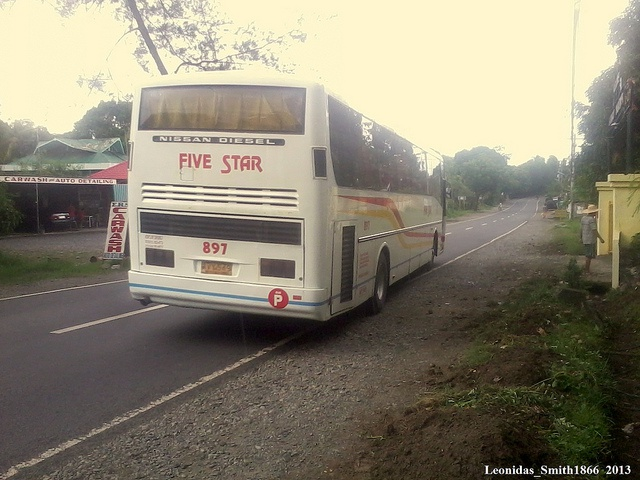Describe the objects in this image and their specific colors. I can see bus in ivory, gray, lightgray, darkgray, and beige tones, people in ivory, gray, darkgreen, tan, and black tones, car in ivory, black, gray, and darkgray tones, people in black and ivory tones, and people in ivory, gray, and darkgray tones in this image. 